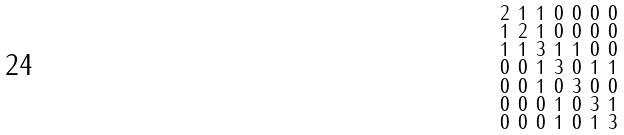<formula> <loc_0><loc_0><loc_500><loc_500>\begin{smallmatrix} 2 & 1 & 1 & 0 & 0 & 0 & 0 \\ 1 & 2 & 1 & 0 & 0 & 0 & 0 \\ 1 & 1 & 3 & 1 & 1 & 0 & 0 \\ 0 & 0 & 1 & 3 & 0 & 1 & 1 \\ 0 & 0 & 1 & 0 & 3 & 0 & 0 \\ 0 & 0 & 0 & 1 & 0 & 3 & 1 \\ 0 & 0 & 0 & 1 & 0 & 1 & 3 \end{smallmatrix}</formula> 